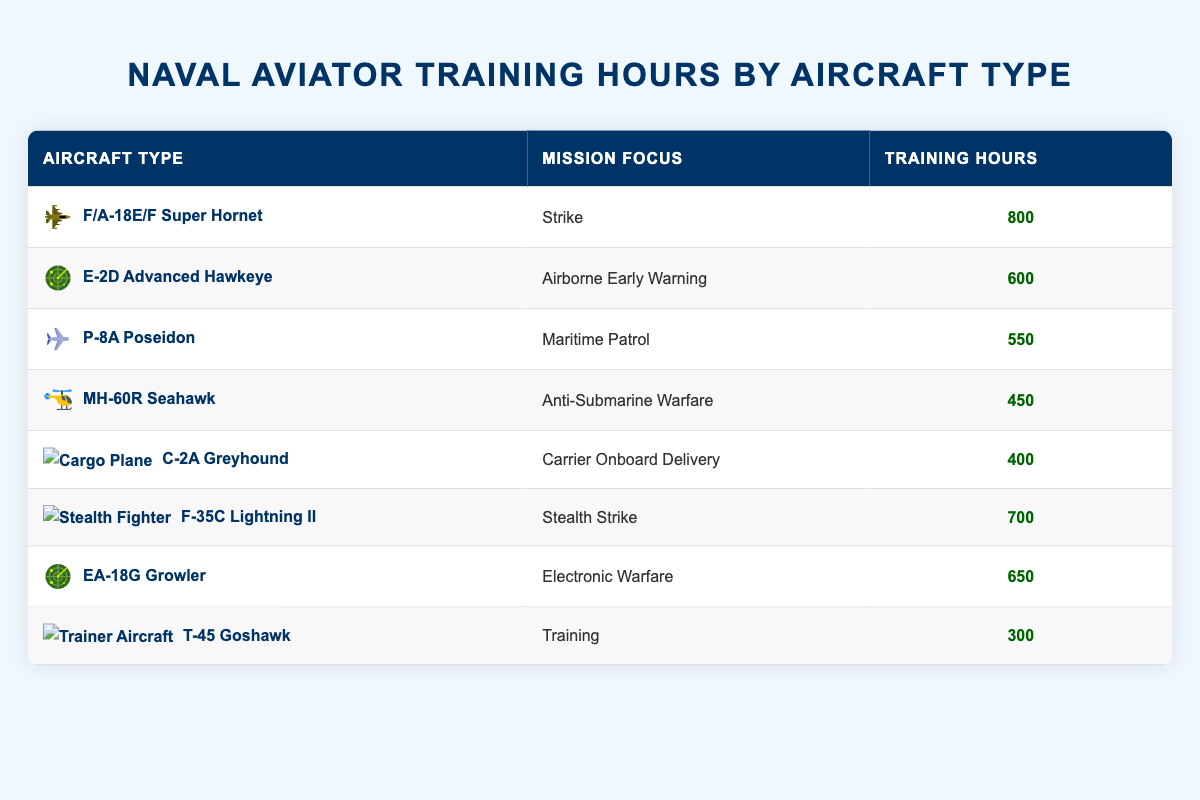What is the total number of training hours for all aircraft types? To find the total training hours, we sum the training hours of all aircraft types listed: 800 + 600 + 550 + 450 + 400 + 700 + 650 + 300 = 4050.
Answer: 4050 Which aircraft type has the highest training hours? By reviewing the training hours for each aircraft type, the F/A-18E/F Super Hornet has the highest at 800 hours.
Answer: F/A-18E/F Super Hornet Is the training hours for the EA-18G Growler more than that of the MH-60R Seahawk? The training hours for the EA-18G Growler is 650, while the MH-60R Seahawk has 450. Since 650 is more than 450, the statement is true.
Answer: Yes What is the average number of training hours for the aircraft types focused on strike missions? The only strike missions are the F/A-18E/F Super Hornet (800) and the F-35C Lightning II (700). We sum these hours to get 800 + 700 = 1500 and divide by 2 to get the average, which is 750.
Answer: 750 How many aircraft types have training hours under 500? After reviewing the table, the MH-60R Seahawk (450), C-2A Greyhound (400), and T-45 Goshawk (300) have training hours under 500. This counts as three aircraft types.
Answer: 3 Is it true that the C-2A Greyhound requires more training hours than the T-45 Goshawk? The training hours for C-2A Greyhound is 400 while for T-45 Goshawk, it is 300. Since 400 is greater than 300, the statement is true.
Answer: Yes What mission focus has the least amount of training hours and how many hours are needed? Reviewing the training hours, the T-45 Goshawk under the Training mission focus has the least at 300 hours.
Answer: Training, 300 How many more training hours are needed for the P-8A Poseidon compared to the T-45 Goshawk? The P-8A Poseidon has 550 training hours and the T-45 Goshawk has 300. To find the difference, we subtract: 550 - 300 = 250.
Answer: 250 